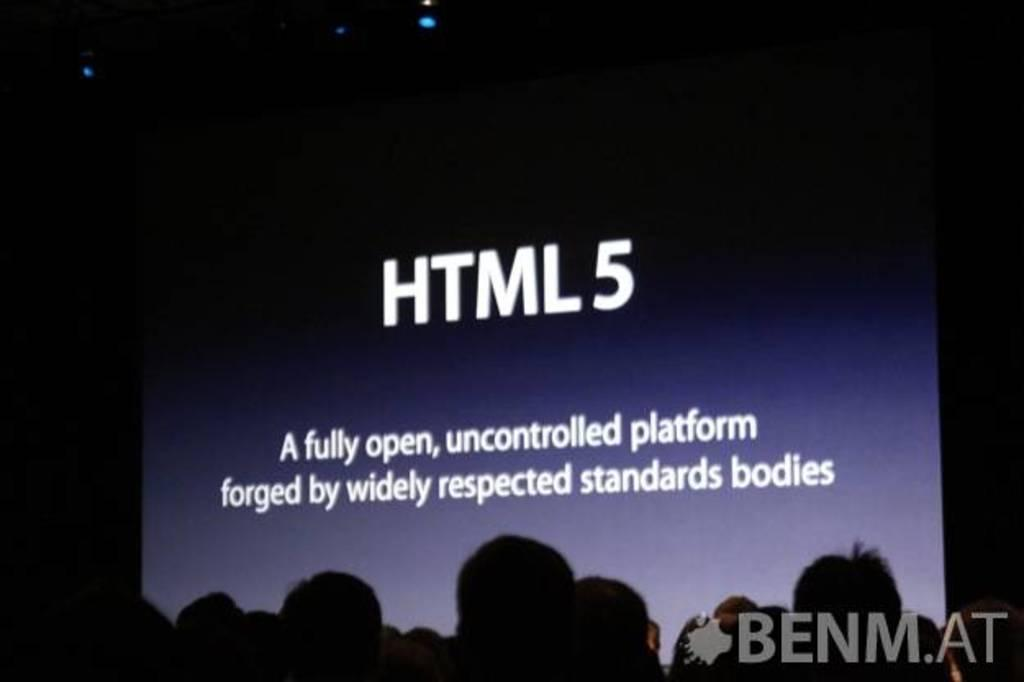Who or what can be seen in the image? There are people in the image. What is in front of the people? There is a screen with text in front of the people. Are there any trees visible in the image? There is no mention of trees in the provided facts, so we cannot determine if there are any trees visible in the image. 